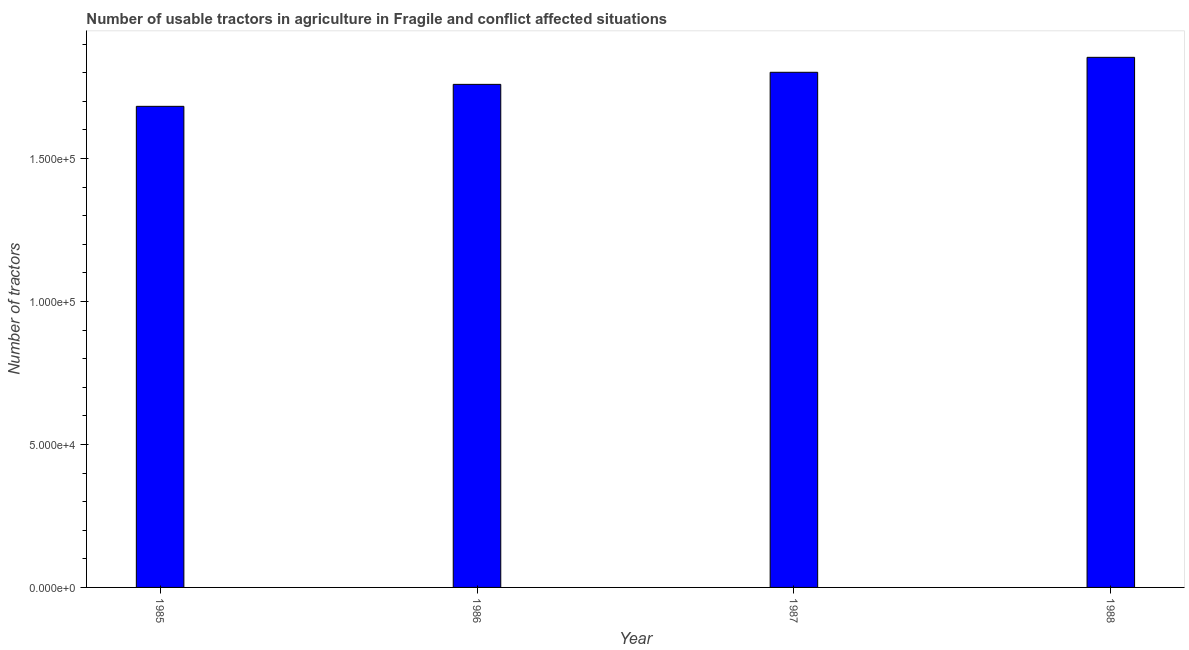Does the graph contain any zero values?
Make the answer very short. No. What is the title of the graph?
Your response must be concise. Number of usable tractors in agriculture in Fragile and conflict affected situations. What is the label or title of the X-axis?
Keep it short and to the point. Year. What is the label or title of the Y-axis?
Your answer should be compact. Number of tractors. What is the number of tractors in 1985?
Offer a terse response. 1.68e+05. Across all years, what is the maximum number of tractors?
Ensure brevity in your answer.  1.85e+05. Across all years, what is the minimum number of tractors?
Make the answer very short. 1.68e+05. In which year was the number of tractors maximum?
Your answer should be very brief. 1988. In which year was the number of tractors minimum?
Your answer should be very brief. 1985. What is the sum of the number of tractors?
Your response must be concise. 7.10e+05. What is the difference between the number of tractors in 1986 and 1987?
Keep it short and to the point. -4223. What is the average number of tractors per year?
Your response must be concise. 1.77e+05. What is the median number of tractors?
Offer a very short reply. 1.78e+05. In how many years, is the number of tractors greater than 80000 ?
Give a very brief answer. 4. Do a majority of the years between 1986 and 1985 (inclusive) have number of tractors greater than 20000 ?
Your answer should be compact. No. What is the ratio of the number of tractors in 1985 to that in 1986?
Your response must be concise. 0.96. Is the difference between the number of tractors in 1985 and 1986 greater than the difference between any two years?
Provide a succinct answer. No. What is the difference between the highest and the second highest number of tractors?
Provide a succinct answer. 5231. What is the difference between the highest and the lowest number of tractors?
Your answer should be very brief. 1.71e+04. In how many years, is the number of tractors greater than the average number of tractors taken over all years?
Your response must be concise. 2. Are all the bars in the graph horizontal?
Ensure brevity in your answer.  No. What is the difference between two consecutive major ticks on the Y-axis?
Your answer should be compact. 5.00e+04. What is the Number of tractors in 1985?
Offer a very short reply. 1.68e+05. What is the Number of tractors of 1986?
Ensure brevity in your answer.  1.76e+05. What is the Number of tractors of 1987?
Offer a terse response. 1.80e+05. What is the Number of tractors of 1988?
Make the answer very short. 1.85e+05. What is the difference between the Number of tractors in 1985 and 1986?
Give a very brief answer. -7679. What is the difference between the Number of tractors in 1985 and 1987?
Make the answer very short. -1.19e+04. What is the difference between the Number of tractors in 1985 and 1988?
Give a very brief answer. -1.71e+04. What is the difference between the Number of tractors in 1986 and 1987?
Provide a short and direct response. -4223. What is the difference between the Number of tractors in 1986 and 1988?
Provide a short and direct response. -9454. What is the difference between the Number of tractors in 1987 and 1988?
Offer a terse response. -5231. What is the ratio of the Number of tractors in 1985 to that in 1986?
Keep it short and to the point. 0.96. What is the ratio of the Number of tractors in 1985 to that in 1987?
Offer a terse response. 0.93. What is the ratio of the Number of tractors in 1985 to that in 1988?
Provide a succinct answer. 0.91. What is the ratio of the Number of tractors in 1986 to that in 1988?
Offer a very short reply. 0.95. 